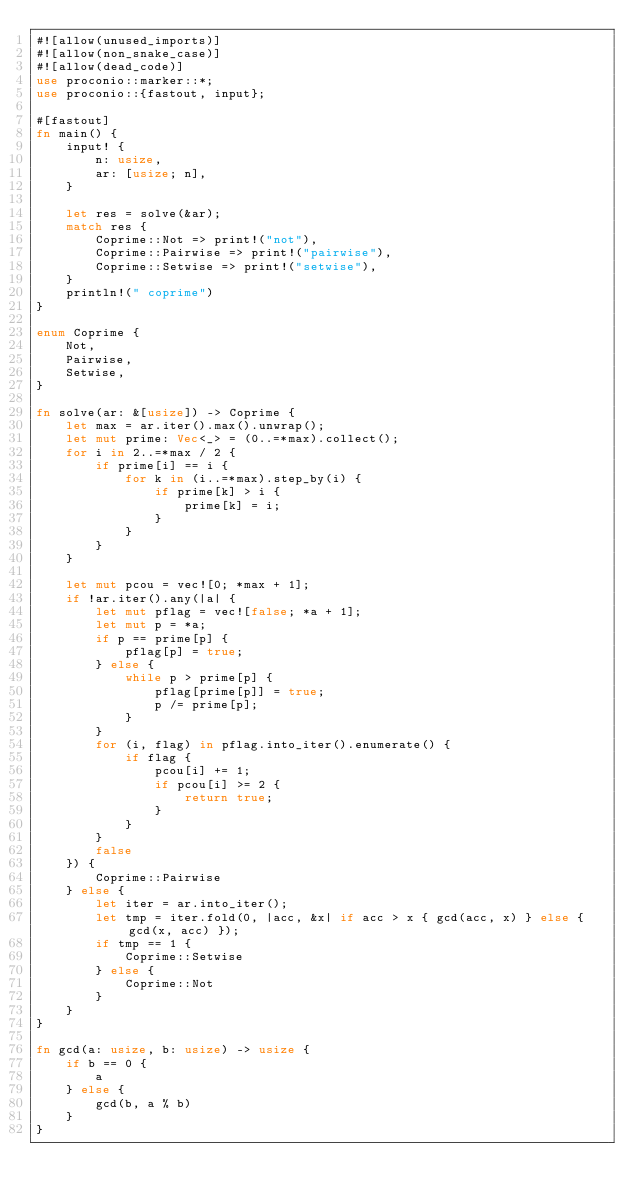Convert code to text. <code><loc_0><loc_0><loc_500><loc_500><_Rust_>#![allow(unused_imports)]
#![allow(non_snake_case)]
#![allow(dead_code)]
use proconio::marker::*;
use proconio::{fastout, input};

#[fastout]
fn main() {
    input! {
        n: usize,
        ar: [usize; n],
    }

    let res = solve(&ar);
    match res {
        Coprime::Not => print!("not"),
        Coprime::Pairwise => print!("pairwise"),
        Coprime::Setwise => print!("setwise"),
    }
    println!(" coprime")
}

enum Coprime {
    Not,
    Pairwise,
    Setwise,
}

fn solve(ar: &[usize]) -> Coprime {
    let max = ar.iter().max().unwrap();
    let mut prime: Vec<_> = (0..=*max).collect();
    for i in 2..=*max / 2 {
        if prime[i] == i {
            for k in (i..=*max).step_by(i) {
                if prime[k] > i {
                    prime[k] = i;
                }
            }
        }
    }

    let mut pcou = vec![0; *max + 1];
    if !ar.iter().any(|a| {
        let mut pflag = vec![false; *a + 1];
        let mut p = *a;
        if p == prime[p] {
            pflag[p] = true;
        } else {
            while p > prime[p] {
                pflag[prime[p]] = true;
                p /= prime[p];
            }
        }
        for (i, flag) in pflag.into_iter().enumerate() {
            if flag {
                pcou[i] += 1;
                if pcou[i] >= 2 {
                    return true;
                }
            }
        }
        false
    }) {
        Coprime::Pairwise
    } else {
        let iter = ar.into_iter();
        let tmp = iter.fold(0, |acc, &x| if acc > x { gcd(acc, x) } else { gcd(x, acc) });
        if tmp == 1 {
            Coprime::Setwise
        } else {
            Coprime::Not
        }
    }
}

fn gcd(a: usize, b: usize) -> usize {
    if b == 0 {
        a
    } else {
        gcd(b, a % b)
    }
}
</code> 